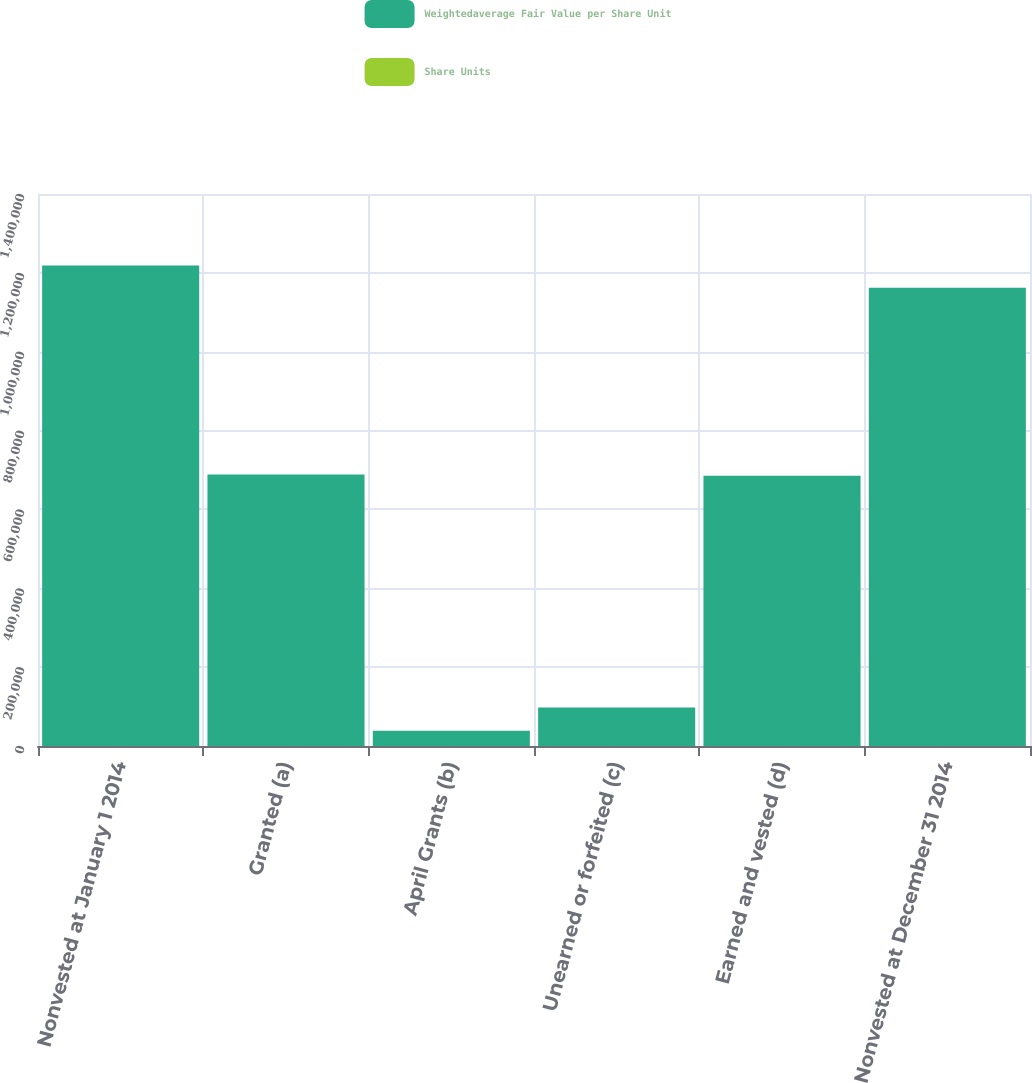<chart> <loc_0><loc_0><loc_500><loc_500><stacked_bar_chart><ecel><fcel>Nonvested at January 1 2014<fcel>Granted (a)<fcel>April Grants (b)<fcel>Unearned or forfeited (c)<fcel>Earned and vested (d)<fcel>Nonvested at December 31 2014<nl><fcel>Weightedaverage Fair Value per Share Unit<fcel>1.21854e+06<fcel>688323<fcel>38559<fcel>97432<fcel>685617<fcel>1.16238e+06<nl><fcel>Share Units<fcel>33.23<fcel>38.9<fcel>50.34<fcel>34.42<fcel>36.12<fcel>35.35<nl></chart> 